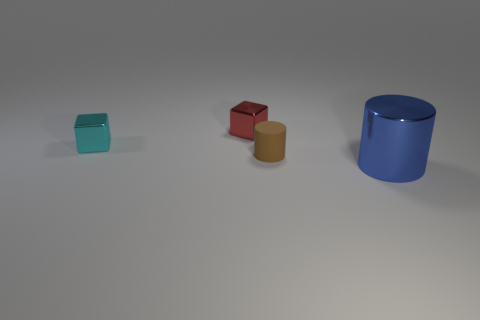The metallic object that is in front of the small brown matte cylinder has what shape?
Provide a short and direct response. Cylinder. There is a metal thing to the right of the cylinder on the left side of the metallic object in front of the tiny cylinder; what is its shape?
Make the answer very short. Cylinder. What number of things are big brown metal balls or brown cylinders?
Ensure brevity in your answer.  1. Do the shiny object right of the red metal block and the small object right of the small red block have the same shape?
Your response must be concise. Yes. What number of objects are both in front of the tiny cyan cube and on the left side of the blue thing?
Your answer should be very brief. 1. How many other objects are the same size as the blue object?
Provide a short and direct response. 0. There is a tiny object that is both in front of the red thing and behind the small brown matte cylinder; what is its material?
Provide a short and direct response. Metal. What is the size of the matte object that is the same shape as the large blue metallic object?
Provide a succinct answer. Small. There is a metallic thing that is both right of the tiny cyan metal block and behind the blue object; what shape is it?
Make the answer very short. Cube. Do the brown cylinder and the shiny block that is to the left of the small red metal object have the same size?
Your answer should be very brief. Yes. 